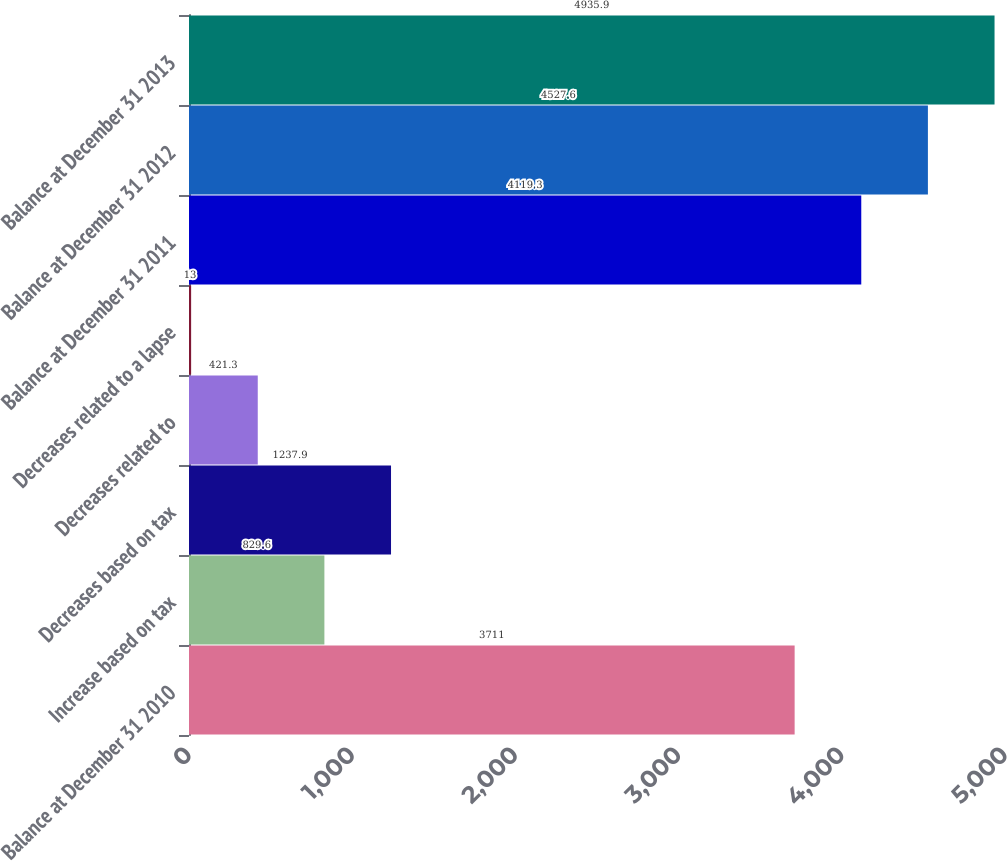Convert chart to OTSL. <chart><loc_0><loc_0><loc_500><loc_500><bar_chart><fcel>Balance at December 31 2010<fcel>Increase based on tax<fcel>Decreases based on tax<fcel>Decreases related to<fcel>Decreases related to a lapse<fcel>Balance at December 31 2011<fcel>Balance at December 31 2012<fcel>Balance at December 31 2013<nl><fcel>3711<fcel>829.6<fcel>1237.9<fcel>421.3<fcel>13<fcel>4119.3<fcel>4527.6<fcel>4935.9<nl></chart> 